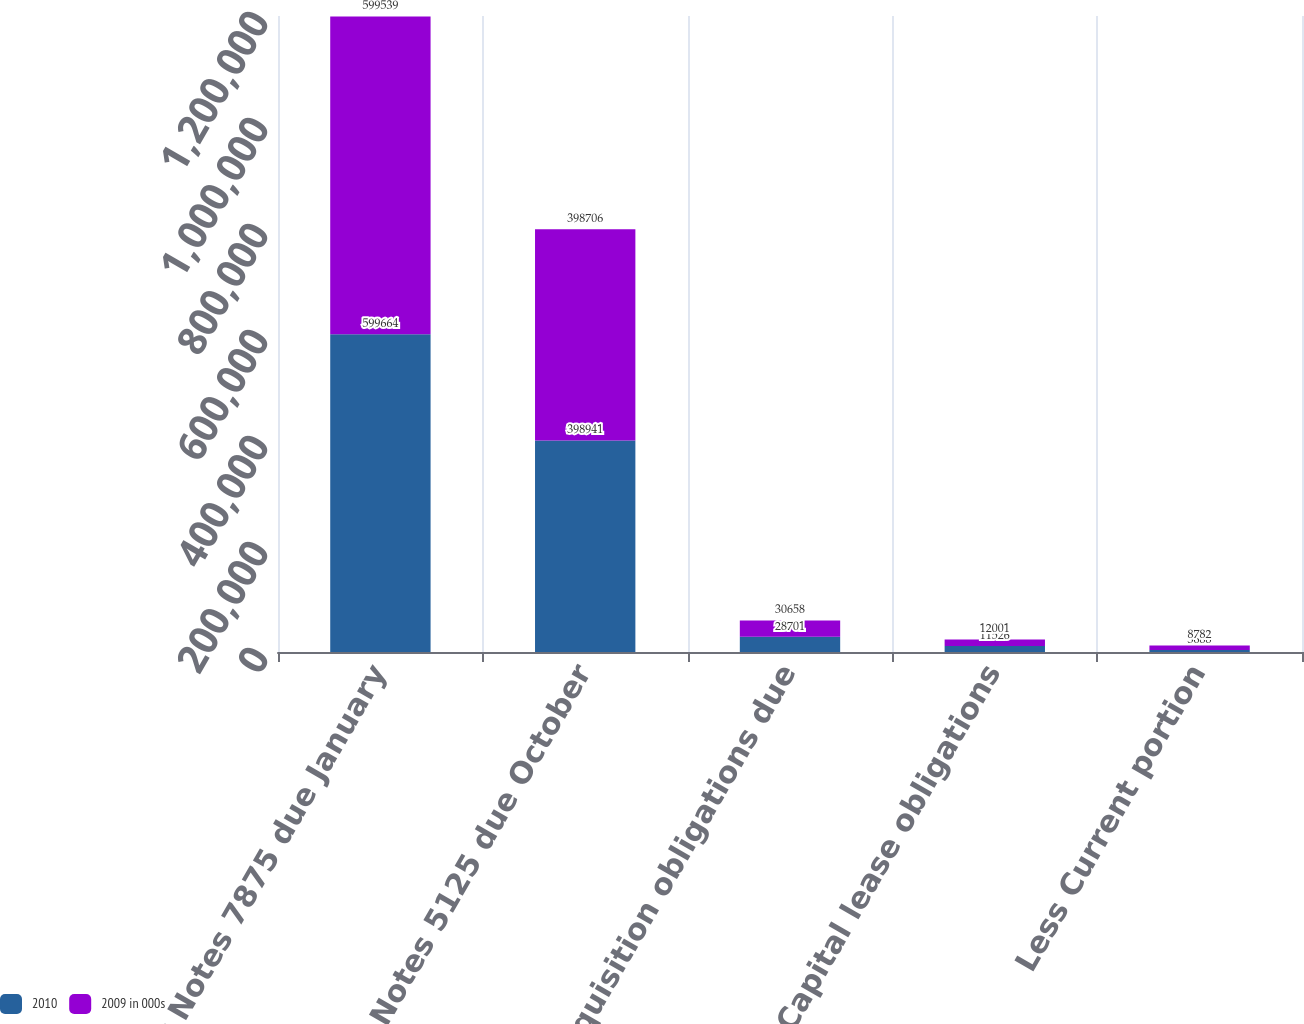Convert chart. <chart><loc_0><loc_0><loc_500><loc_500><stacked_bar_chart><ecel><fcel>Senior Notes 7875 due January<fcel>Senior Notes 5125 due October<fcel>Acquisition obligations due<fcel>Capital lease obligations<fcel>Less Current portion<nl><fcel>2010<fcel>599664<fcel>398941<fcel>28701<fcel>11526<fcel>3688<nl><fcel>2009 in 000s<fcel>599539<fcel>398706<fcel>30658<fcel>12001<fcel>8782<nl></chart> 